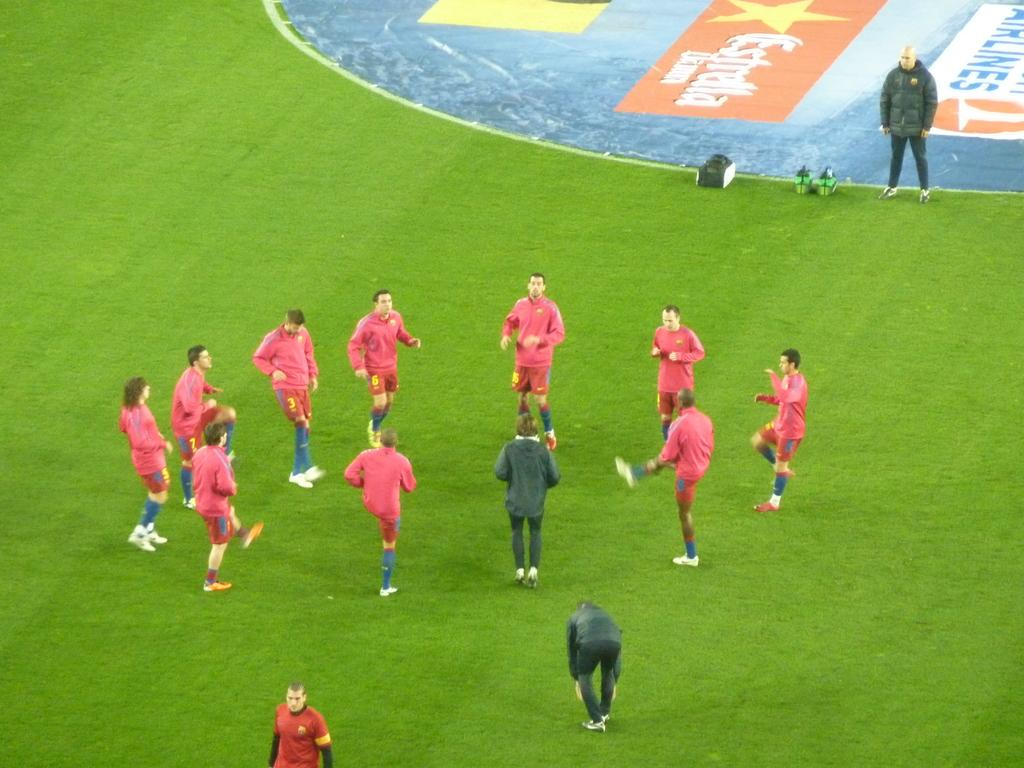Provide a one-sentence caption for the provided image. Soccer players on a field with an advertisement for airlines nearby. 